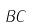<formula> <loc_0><loc_0><loc_500><loc_500>B C</formula> 